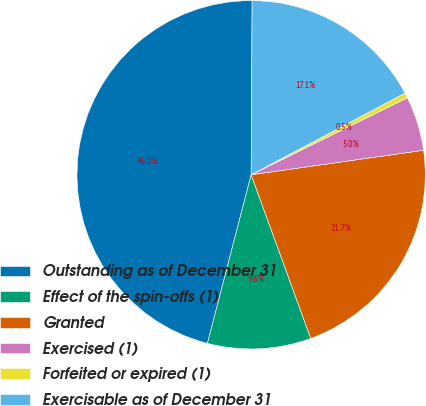<chart> <loc_0><loc_0><loc_500><loc_500><pie_chart><fcel>Outstanding as of December 31<fcel>Effect of the spin-offs (1)<fcel>Granted<fcel>Exercised (1)<fcel>Forfeited or expired (1)<fcel>Exercisable as of December 31<nl><fcel>46.05%<fcel>9.6%<fcel>21.69%<fcel>5.04%<fcel>0.48%<fcel>17.14%<nl></chart> 